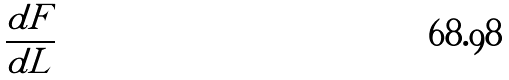<formula> <loc_0><loc_0><loc_500><loc_500>\frac { d F } { d L }</formula> 